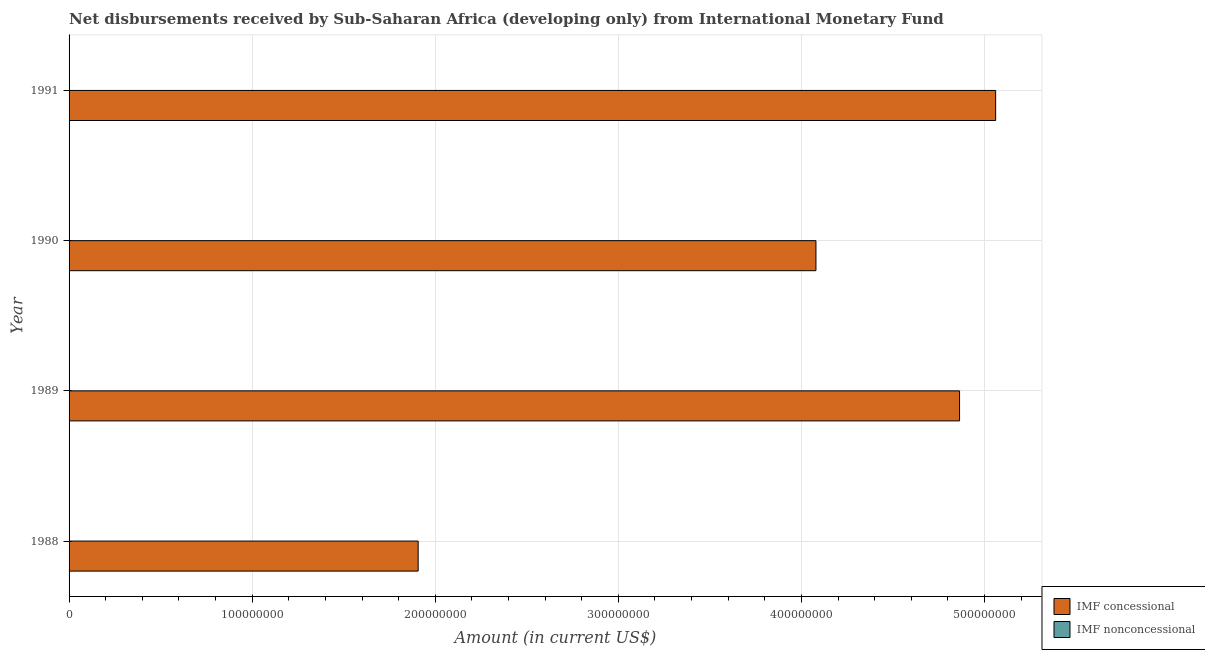Are the number of bars on each tick of the Y-axis equal?
Ensure brevity in your answer.  Yes. How many bars are there on the 3rd tick from the bottom?
Keep it short and to the point. 1. In how many cases, is the number of bars for a given year not equal to the number of legend labels?
Your answer should be compact. 4. What is the net concessional disbursements from imf in 1990?
Make the answer very short. 4.08e+08. Across all years, what is the maximum net concessional disbursements from imf?
Provide a succinct answer. 5.06e+08. In which year was the net concessional disbursements from imf maximum?
Offer a terse response. 1991. What is the total net non concessional disbursements from imf in the graph?
Make the answer very short. 0. What is the difference between the net concessional disbursements from imf in 1990 and that in 1991?
Your response must be concise. -9.81e+07. What is the difference between the net non concessional disbursements from imf in 1989 and the net concessional disbursements from imf in 1988?
Keep it short and to the point. -1.91e+08. What is the average net non concessional disbursements from imf per year?
Provide a succinct answer. 0. What is the ratio of the net concessional disbursements from imf in 1988 to that in 1990?
Give a very brief answer. 0.47. What is the difference between the highest and the second highest net concessional disbursements from imf?
Your response must be concise. 1.97e+07. What is the difference between the highest and the lowest net concessional disbursements from imf?
Provide a short and direct response. 3.15e+08. In how many years, is the net concessional disbursements from imf greater than the average net concessional disbursements from imf taken over all years?
Your answer should be compact. 3. Is the sum of the net concessional disbursements from imf in 1988 and 1991 greater than the maximum net non concessional disbursements from imf across all years?
Your answer should be very brief. Yes. Are all the bars in the graph horizontal?
Ensure brevity in your answer.  Yes. Are the values on the major ticks of X-axis written in scientific E-notation?
Provide a short and direct response. No. Does the graph contain grids?
Offer a terse response. Yes. How many legend labels are there?
Provide a short and direct response. 2. How are the legend labels stacked?
Your answer should be very brief. Vertical. What is the title of the graph?
Ensure brevity in your answer.  Net disbursements received by Sub-Saharan Africa (developing only) from International Monetary Fund. Does "Females" appear as one of the legend labels in the graph?
Provide a succinct answer. No. What is the Amount (in current US$) of IMF concessional in 1988?
Provide a succinct answer. 1.91e+08. What is the Amount (in current US$) of IMF concessional in 1989?
Your answer should be compact. 4.86e+08. What is the Amount (in current US$) in IMF concessional in 1990?
Your answer should be very brief. 4.08e+08. What is the Amount (in current US$) in IMF concessional in 1991?
Keep it short and to the point. 5.06e+08. Across all years, what is the maximum Amount (in current US$) of IMF concessional?
Give a very brief answer. 5.06e+08. Across all years, what is the minimum Amount (in current US$) in IMF concessional?
Provide a succinct answer. 1.91e+08. What is the total Amount (in current US$) of IMF concessional in the graph?
Offer a terse response. 1.59e+09. What is the difference between the Amount (in current US$) in IMF concessional in 1988 and that in 1989?
Provide a short and direct response. -2.96e+08. What is the difference between the Amount (in current US$) of IMF concessional in 1988 and that in 1990?
Give a very brief answer. -2.17e+08. What is the difference between the Amount (in current US$) of IMF concessional in 1988 and that in 1991?
Your answer should be compact. -3.15e+08. What is the difference between the Amount (in current US$) of IMF concessional in 1989 and that in 1990?
Your answer should be very brief. 7.84e+07. What is the difference between the Amount (in current US$) in IMF concessional in 1989 and that in 1991?
Offer a terse response. -1.97e+07. What is the difference between the Amount (in current US$) of IMF concessional in 1990 and that in 1991?
Offer a terse response. -9.81e+07. What is the average Amount (in current US$) in IMF concessional per year?
Provide a short and direct response. 3.98e+08. What is the ratio of the Amount (in current US$) of IMF concessional in 1988 to that in 1989?
Ensure brevity in your answer.  0.39. What is the ratio of the Amount (in current US$) of IMF concessional in 1988 to that in 1990?
Your response must be concise. 0.47. What is the ratio of the Amount (in current US$) in IMF concessional in 1988 to that in 1991?
Your answer should be very brief. 0.38. What is the ratio of the Amount (in current US$) in IMF concessional in 1989 to that in 1990?
Your response must be concise. 1.19. What is the ratio of the Amount (in current US$) of IMF concessional in 1989 to that in 1991?
Provide a short and direct response. 0.96. What is the ratio of the Amount (in current US$) in IMF concessional in 1990 to that in 1991?
Offer a terse response. 0.81. What is the difference between the highest and the second highest Amount (in current US$) of IMF concessional?
Offer a terse response. 1.97e+07. What is the difference between the highest and the lowest Amount (in current US$) in IMF concessional?
Provide a short and direct response. 3.15e+08. 